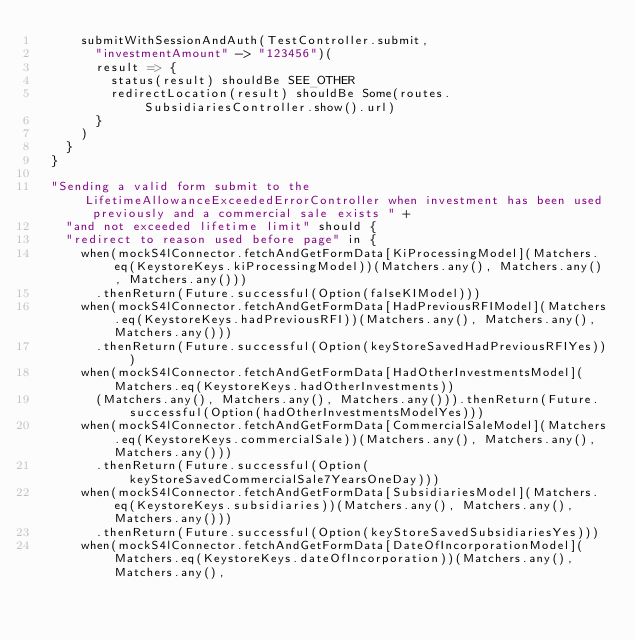<code> <loc_0><loc_0><loc_500><loc_500><_Scala_>      submitWithSessionAndAuth(TestController.submit,
        "investmentAmount" -> "123456")(
        result => {
          status(result) shouldBe SEE_OTHER
          redirectLocation(result) shouldBe Some(routes.SubsidiariesController.show().url)
        }
      )
    }
  }

  "Sending a valid form submit to the LifetimeAllowanceExceededErrorController when investment has been used previously and a commercial sale exists " +
    "and not exceeded lifetime limit" should {
    "redirect to reason used before page" in {
      when(mockS4lConnector.fetchAndGetFormData[KiProcessingModel](Matchers.eq(KeystoreKeys.kiProcessingModel))(Matchers.any(), Matchers.any(), Matchers.any()))
        .thenReturn(Future.successful(Option(falseKIModel)))
      when(mockS4lConnector.fetchAndGetFormData[HadPreviousRFIModel](Matchers.eq(KeystoreKeys.hadPreviousRFI))(Matchers.any(), Matchers.any(), Matchers.any()))
        .thenReturn(Future.successful(Option(keyStoreSavedHadPreviousRFIYes)))
      when(mockS4lConnector.fetchAndGetFormData[HadOtherInvestmentsModel](Matchers.eq(KeystoreKeys.hadOtherInvestments))
        (Matchers.any(), Matchers.any(), Matchers.any())).thenReturn(Future.successful(Option(hadOtherInvestmentsModelYes)))
      when(mockS4lConnector.fetchAndGetFormData[CommercialSaleModel](Matchers.eq(KeystoreKeys.commercialSale))(Matchers.any(), Matchers.any(), Matchers.any()))
        .thenReturn(Future.successful(Option(keyStoreSavedCommercialSale7YearsOneDay)))
      when(mockS4lConnector.fetchAndGetFormData[SubsidiariesModel](Matchers.eq(KeystoreKeys.subsidiaries))(Matchers.any(), Matchers.any(), Matchers.any()))
        .thenReturn(Future.successful(Option(keyStoreSavedSubsidiariesYes)))
      when(mockS4lConnector.fetchAndGetFormData[DateOfIncorporationModel](Matchers.eq(KeystoreKeys.dateOfIncorporation))(Matchers.any(), Matchers.any(),</code> 